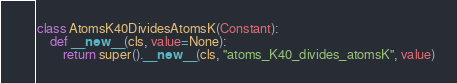<code> <loc_0><loc_0><loc_500><loc_500><_Python_>
class AtomsK40DividesAtomsK(Constant):
    def __new__(cls, value=None):
        return super().__new__(cls, "atoms_K40_divides_atomsK", value)
</code> 